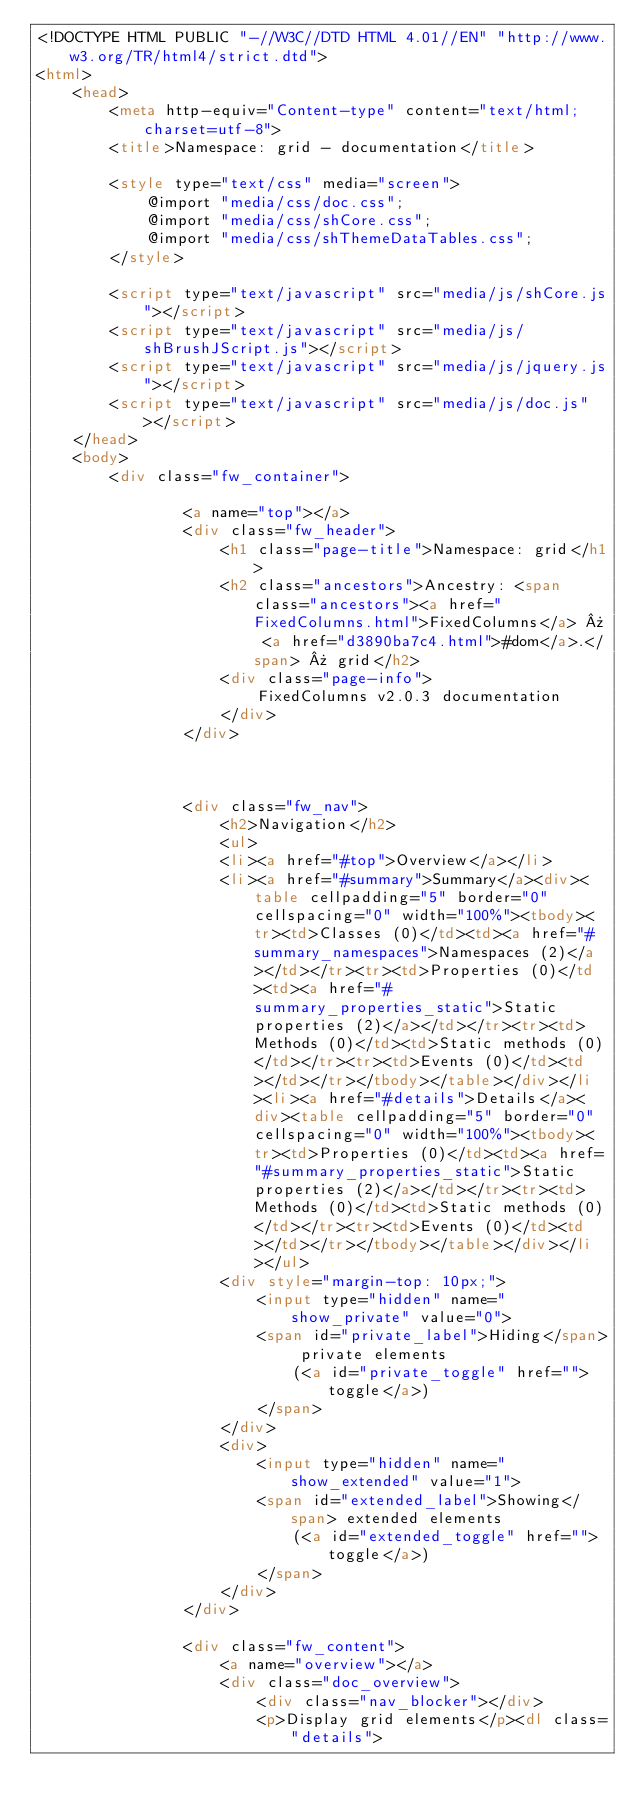Convert code to text. <code><loc_0><loc_0><loc_500><loc_500><_HTML_><!DOCTYPE HTML PUBLIC "-//W3C//DTD HTML 4.01//EN" "http://www.w3.org/TR/html4/strict.dtd">
<html>
	<head>
		<meta http-equiv="Content-type" content="text/html; charset=utf-8">
		<title>Namespace: grid - documentation</title>
  
		<style type="text/css" media="screen">
			@import "media/css/doc.css";
			@import "media/css/shCore.css";
			@import "media/css/shThemeDataTables.css";
		</style>
	
		<script type="text/javascript" src="media/js/shCore.js"></script>
		<script type="text/javascript" src="media/js/shBrushJScript.js"></script>
		<script type="text/javascript" src="media/js/jquery.js"></script>
		<script type="text/javascript" src="media/js/doc.js"></script>
	</head>
	<body>
		<div class="fw_container">
			
				<a name="top"></a>
				<div class="fw_header">
					<h1 class="page-title">Namespace: grid</h1>
					<h2 class="ancestors">Ancestry: <span class="ancestors"><a href="FixedColumns.html">FixedColumns</a> » <a href="d3890ba7c4.html">#dom</a>.</span> » grid</h2>
					<div class="page-info">
						FixedColumns v2.0.3 documentation
					</div>
				</div>

				

				<div class="fw_nav">
					<h2>Navigation</h2>
					<ul>
					<li><a href="#top">Overview</a></li>
					<li><a href="#summary">Summary</a><div><table cellpadding="5" border="0" cellspacing="0" width="100%"><tbody><tr><td>Classes (0)</td><td><a href="#summary_namespaces">Namespaces (2)</a></td></tr><tr><td>Properties (0)</td><td><a href="#summary_properties_static">Static properties (2)</a></td></tr><tr><td>Methods (0)</td><td>Static methods (0)</td></tr><tr><td>Events (0)</td><td></td></tr></tbody></table></div></li><li><a href="#details">Details</a><div><table cellpadding="5" border="0" cellspacing="0" width="100%"><tbody><tr><td>Properties (0)</td><td><a href="#summary_properties_static">Static properties (2)</a></td></tr><tr><td>Methods (0)</td><td>Static methods (0)</td></tr><tr><td>Events (0)</td><td></td></tr></tbody></table></div></li></ul>
					<div style="margin-top: 10px;">
						<input type="hidden" name="show_private" value="0">
						<span id="private_label">Hiding</span> private elements 
							(<a id="private_toggle" href="">toggle</a>)
						</span>
					</div>
					<div>
						<input type="hidden" name="show_extended" value="1">
						<span id="extended_label">Showing</span> extended elements 
							(<a id="extended_toggle" href="">toggle</a>)
						</span>
					</div>
				</div>

				<div class="fw_content">
					<a name="overview"></a>
					<div class="doc_overview">
						<div class="nav_blocker"></div>
						<p>Display grid elements</p><dl class="details">
	</code> 